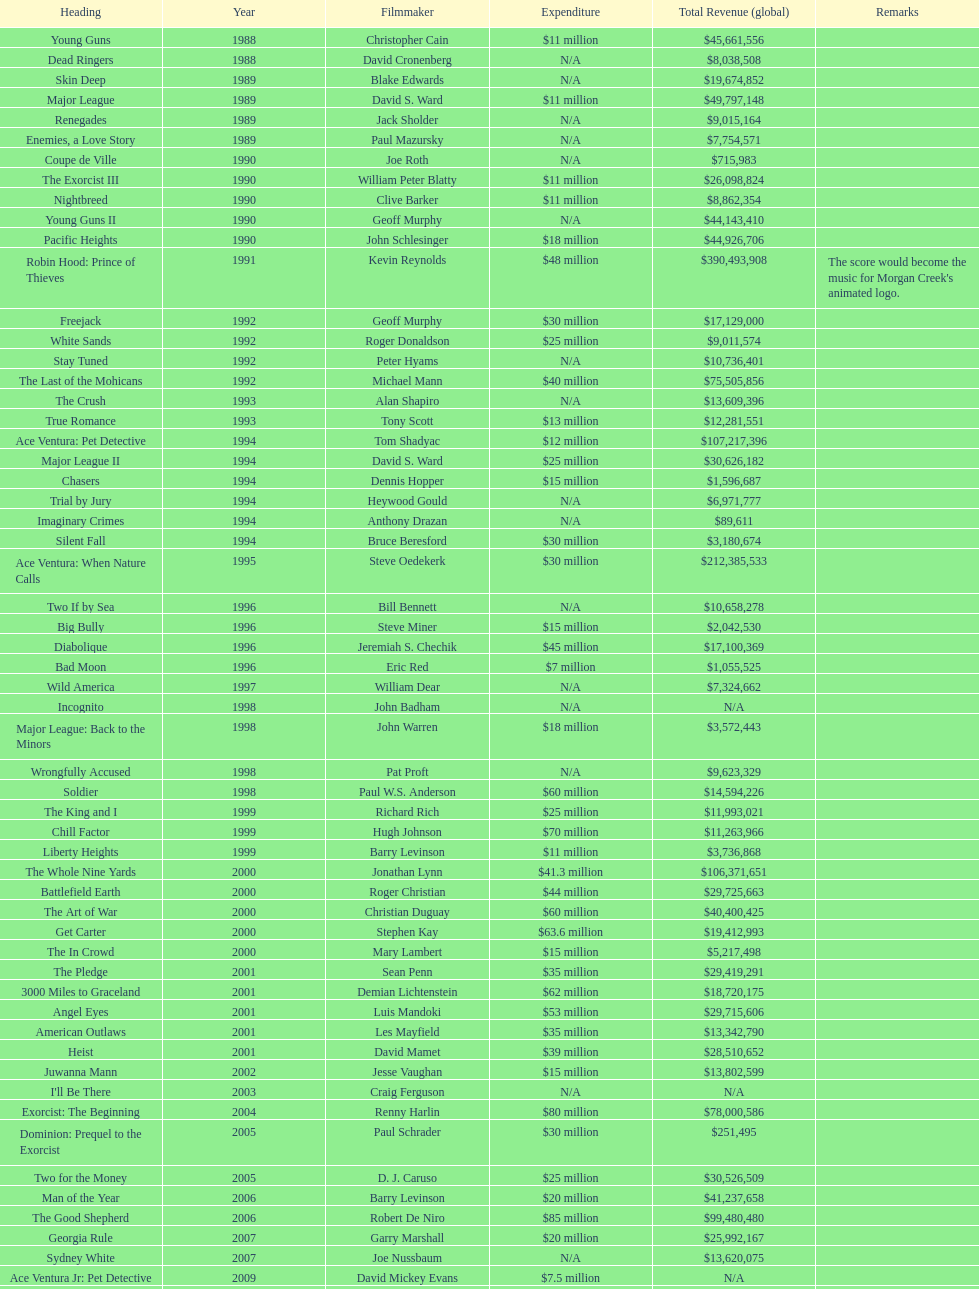What is the top grossing film? Robin Hood: Prince of Thieves. 